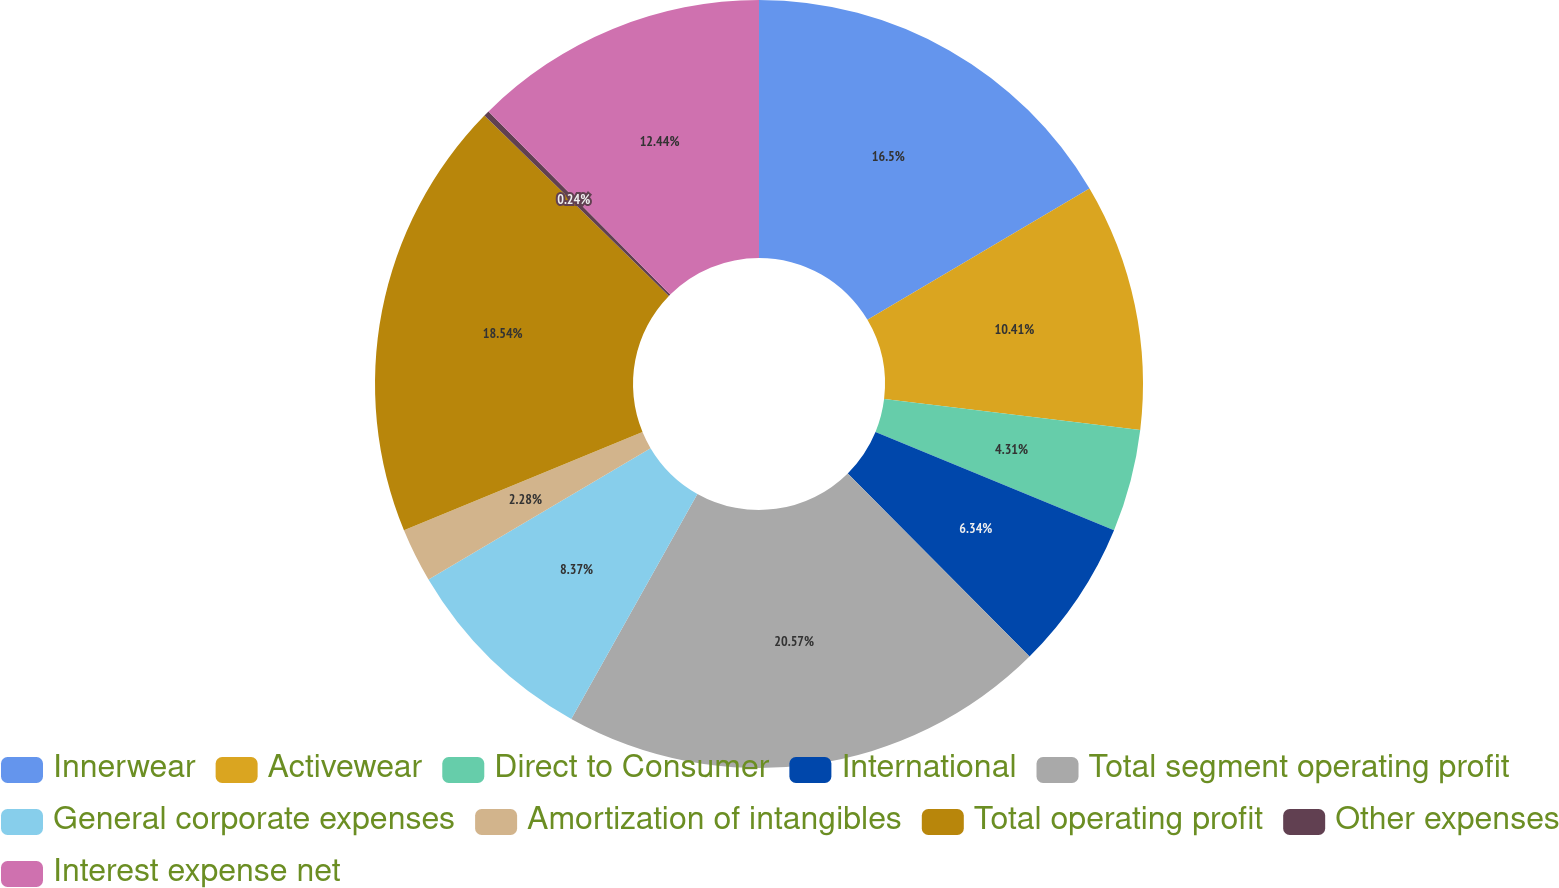Convert chart to OTSL. <chart><loc_0><loc_0><loc_500><loc_500><pie_chart><fcel>Innerwear<fcel>Activewear<fcel>Direct to Consumer<fcel>International<fcel>Total segment operating profit<fcel>General corporate expenses<fcel>Amortization of intangibles<fcel>Total operating profit<fcel>Other expenses<fcel>Interest expense net<nl><fcel>16.5%<fcel>10.41%<fcel>4.31%<fcel>6.34%<fcel>20.57%<fcel>8.37%<fcel>2.28%<fcel>18.54%<fcel>0.24%<fcel>12.44%<nl></chart> 